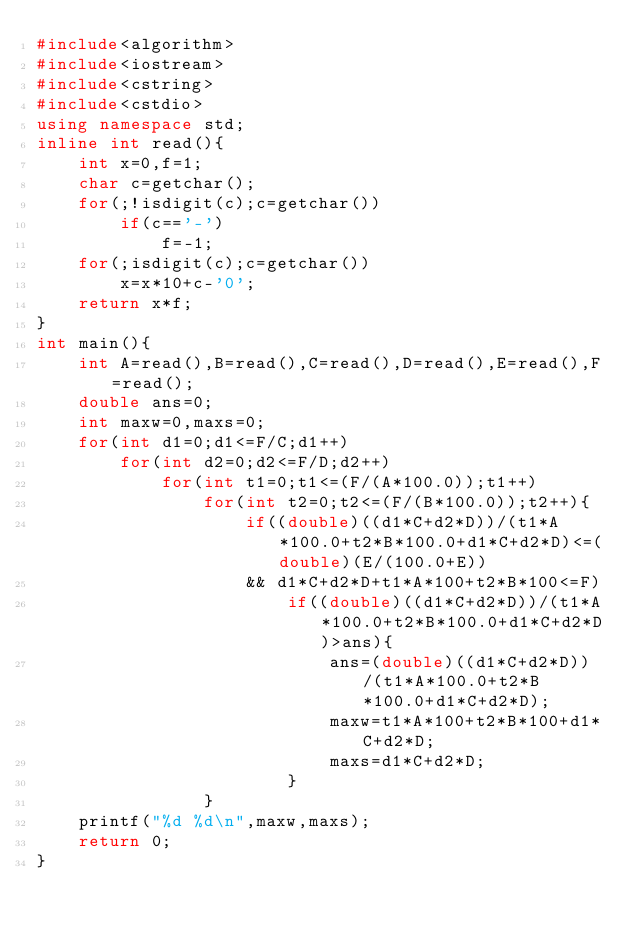<code> <loc_0><loc_0><loc_500><loc_500><_C++_>#include<algorithm>
#include<iostream>
#include<cstring>
#include<cstdio>
using namespace std;
inline int read(){
	int x=0,f=1;
	char c=getchar();
	for(;!isdigit(c);c=getchar())
		if(c=='-')
			f=-1;
	for(;isdigit(c);c=getchar())
		x=x*10+c-'0';
	return x*f;
}
int main(){
	int A=read(),B=read(),C=read(),D=read(),E=read(),F=read();
	double ans=0;
	int maxw=0,maxs=0;
	for(int d1=0;d1<=F/C;d1++)
		for(int d2=0;d2<=F/D;d2++)
			for(int t1=0;t1<=(F/(A*100.0));t1++)
			    for(int t2=0;t2<=(F/(B*100.0));t2++){
			    	if((double)((d1*C+d2*D))/(t1*A*100.0+t2*B*100.0+d1*C+d2*D)<=(double)(E/(100.0+E))
					&& d1*C+d2*D+t1*A*100+t2*B*100<=F)
			    		if((double)((d1*C+d2*D))/(t1*A*100.0+t2*B*100.0+d1*C+d2*D)>ans){
			    			ans=(double)((d1*C+d2*D))/(t1*A*100.0+t2*B*100.0+d1*C+d2*D);
			    			maxw=t1*A*100+t2*B*100+d1*C+d2*D;
			    			maxs=d1*C+d2*D;
						}
				}
	printf("%d %d\n",maxw,maxs);
	return 0;
}
</code> 